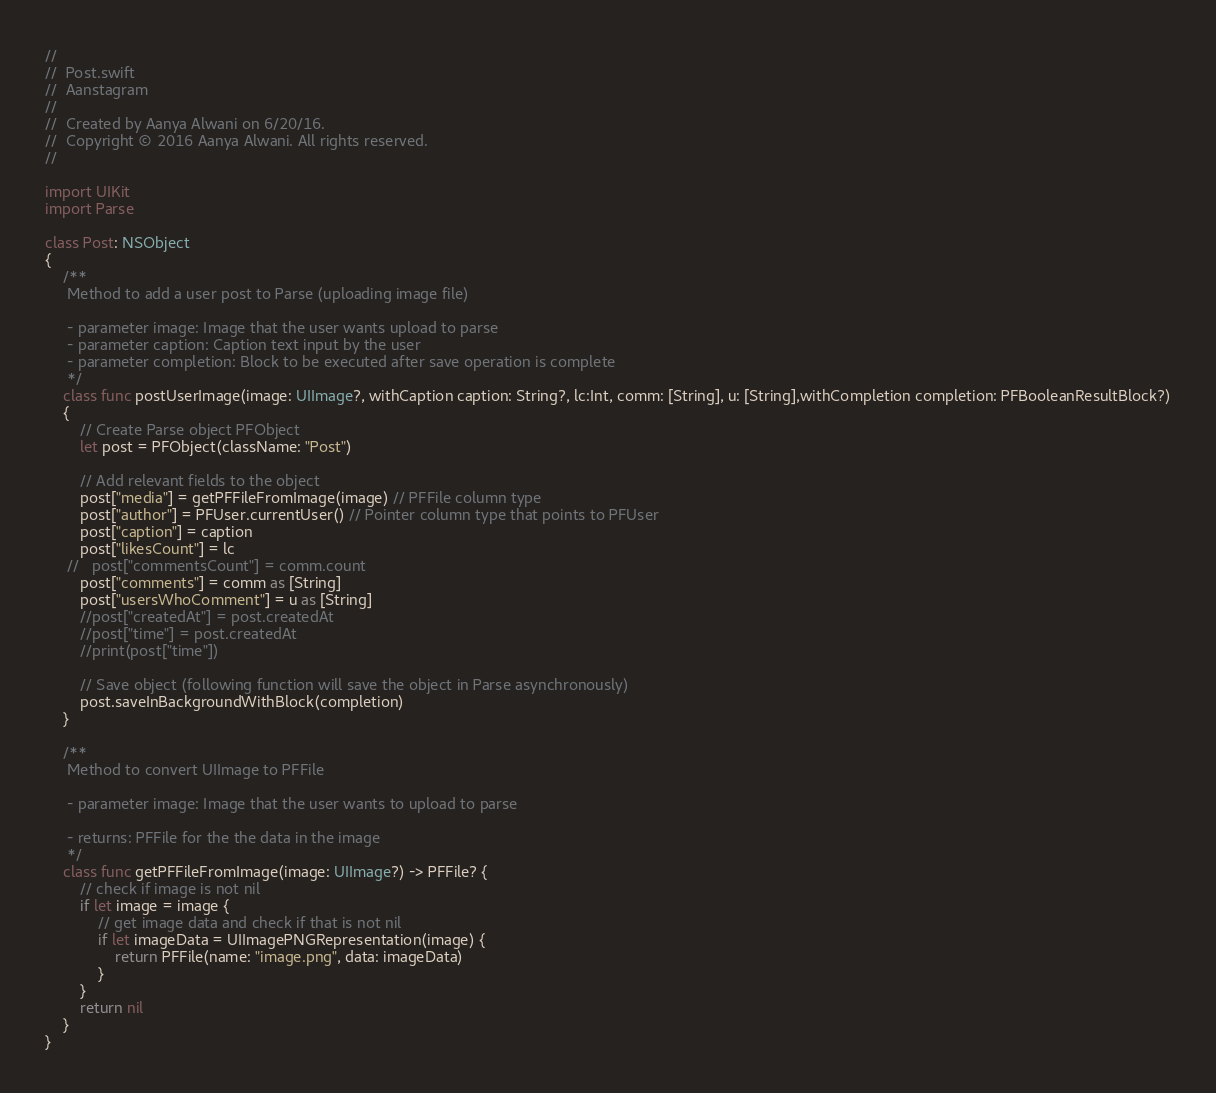Convert code to text. <code><loc_0><loc_0><loc_500><loc_500><_Swift_>//
//  Post.swift
//  Aanstagram
//
//  Created by Aanya Alwani on 6/20/16.
//  Copyright © 2016 Aanya Alwani. All rights reserved.
//

import UIKit
import Parse

class Post: NSObject
{
    /**
     Method to add a user post to Parse (uploading image file)
     
     - parameter image: Image that the user wants upload to parse
     - parameter caption: Caption text input by the user
     - parameter completion: Block to be executed after save operation is complete
     */
    class func postUserImage(image: UIImage?, withCaption caption: String?, lc:Int, comm: [String], u: [String],withCompletion completion: PFBooleanResultBlock?)
    {
        // Create Parse object PFObject
        let post = PFObject(className: "Post")
        
        // Add relevant fields to the object
        post["media"] = getPFFileFromImage(image) // PFFile column type
        post["author"] = PFUser.currentUser() // Pointer column type that points to PFUser
        post["caption"] = caption
        post["likesCount"] = lc
     //   post["commentsCount"] = comm.count
        post["comments"] = comm as [String]
        post["usersWhoComment"] = u as [String]
        //post["createdAt"] = post.createdAt
        //post["time"] = post.createdAt
        //print(post["time"])
        
        // Save object (following function will save the object in Parse asynchronously)
        post.saveInBackgroundWithBlock(completion)
    }
    
    /**
     Method to convert UIImage to PFFile
     
     - parameter image: Image that the user wants to upload to parse
     
     - returns: PFFile for the the data in the image
     */
    class func getPFFileFromImage(image: UIImage?) -> PFFile? {
        // check if image is not nil
        if let image = image {
            // get image data and check if that is not nil
            if let imageData = UIImagePNGRepresentation(image) {
                return PFFile(name: "image.png", data: imageData)
            }
        }
        return nil
    }
}


</code> 